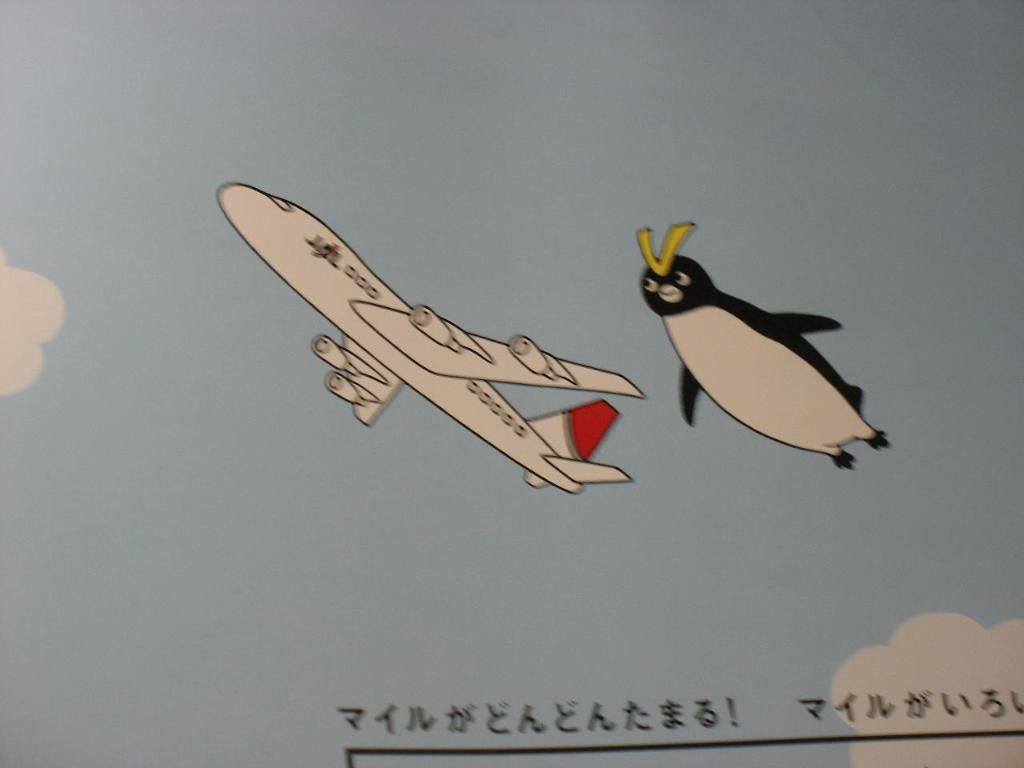What is the main subject of the poster in the image? The poster depicts the sky, clouds, an airplane, and a penguin. What is the setting of the poster? The poster depicts a sky with clouds. What is the poster's content related to? The poster depicts an airplane and a penguin, which suggests it might be related to travel or wildlife. What is written on the paper in the image? There is something written on the paper in the image, but the specific content is not mentioned in the facts. What type of coal is being mined in the image? There is no coal or mining activity present in the image. What is the view from the airplane in the image? The image does not show a view from the airplane, as it only depicts the airplane itself. 